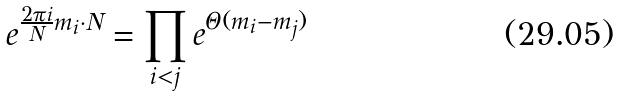<formula> <loc_0><loc_0><loc_500><loc_500>e ^ { \frac { 2 \pi i } { N } m _ { i } \cdot N } = \prod _ { i < j } e ^ { \Theta ( m _ { i } - m _ { j } ) }</formula> 